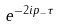Convert formula to latex. <formula><loc_0><loc_0><loc_500><loc_500>e ^ { - 2 i p _ { - } \tau }</formula> 